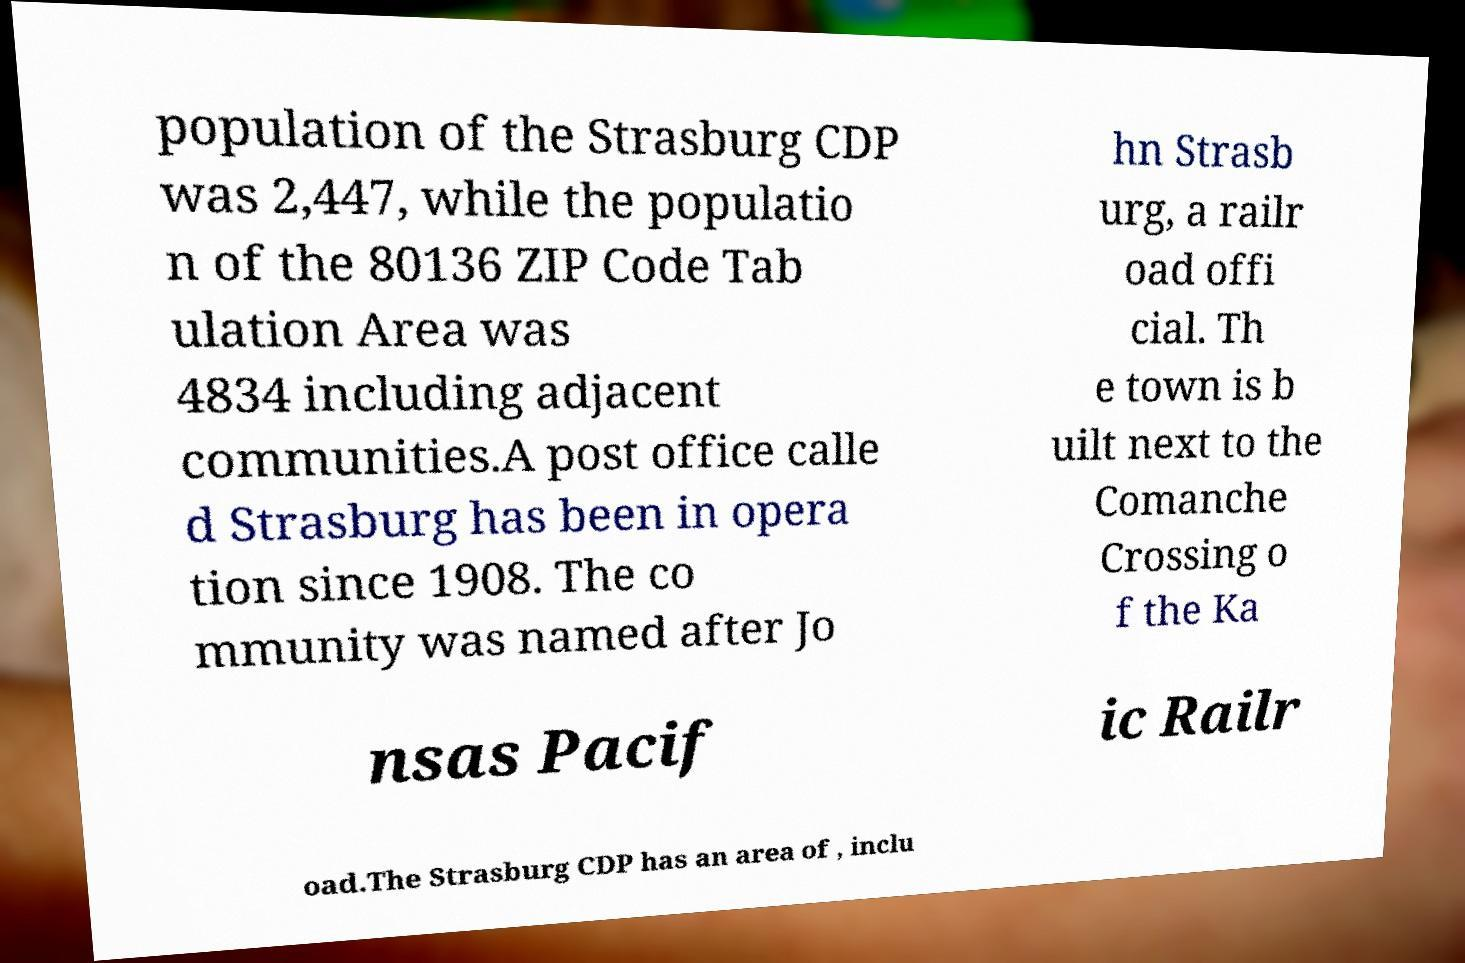What messages or text are displayed in this image? I need them in a readable, typed format. population of the Strasburg CDP was 2,447, while the populatio n of the 80136 ZIP Code Tab ulation Area was 4834 including adjacent communities.A post office calle d Strasburg has been in opera tion since 1908. The co mmunity was named after Jo hn Strasb urg, a railr oad offi cial. Th e town is b uilt next to the Comanche Crossing o f the Ka nsas Pacif ic Railr oad.The Strasburg CDP has an area of , inclu 